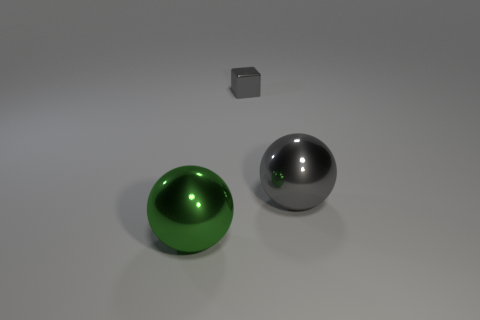Add 2 gray things. How many objects exist? 5 Subtract all cubes. How many objects are left? 2 Subtract all purple blocks. Subtract all gray cylinders. How many blocks are left? 1 Subtract all large green shiny balls. Subtract all small gray metallic things. How many objects are left? 1 Add 1 gray metal balls. How many gray metal balls are left? 2 Add 1 big brown matte things. How many big brown matte things exist? 1 Subtract 1 gray cubes. How many objects are left? 2 